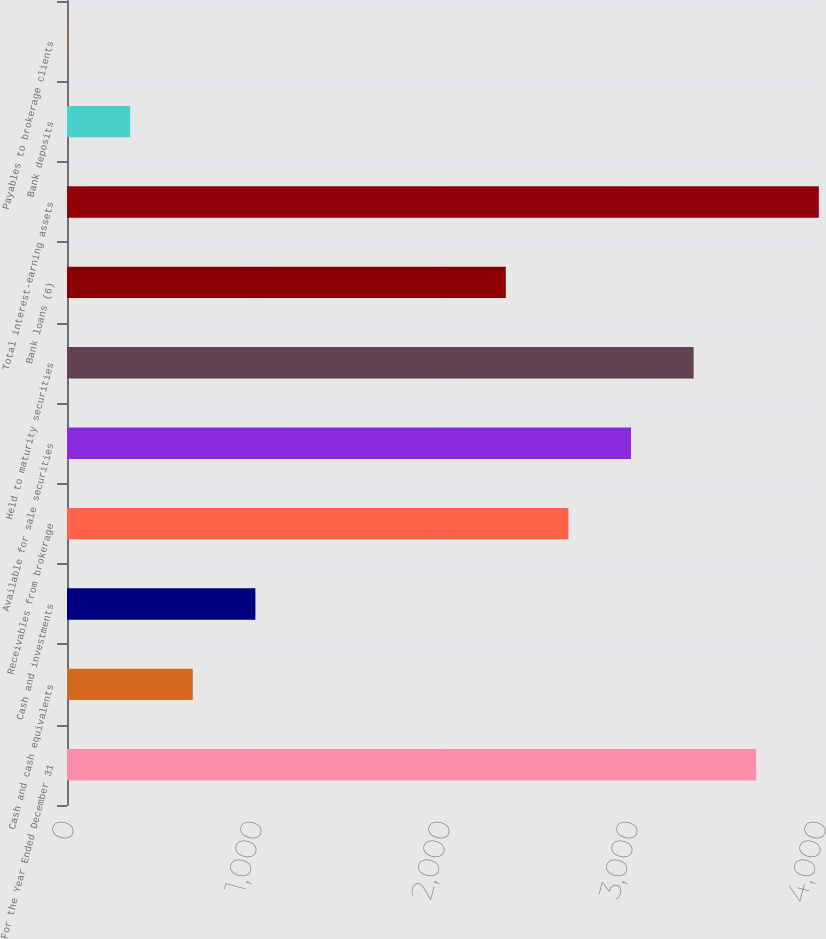Convert chart. <chart><loc_0><loc_0><loc_500><loc_500><bar_chart><fcel>For the Year Ended December 31<fcel>Cash and cash equivalents<fcel>Cash and investments<fcel>Receivables from brokerage<fcel>Available for sale securities<fcel>Held to maturity securities<fcel>Bank loans (6)<fcel>Total interest-earning assets<fcel>Bank deposits<fcel>Payables to brokerage clients<nl><fcel>3666<fcel>669<fcel>1002<fcel>2667<fcel>3000<fcel>3333<fcel>2334<fcel>3999<fcel>336<fcel>3<nl></chart> 